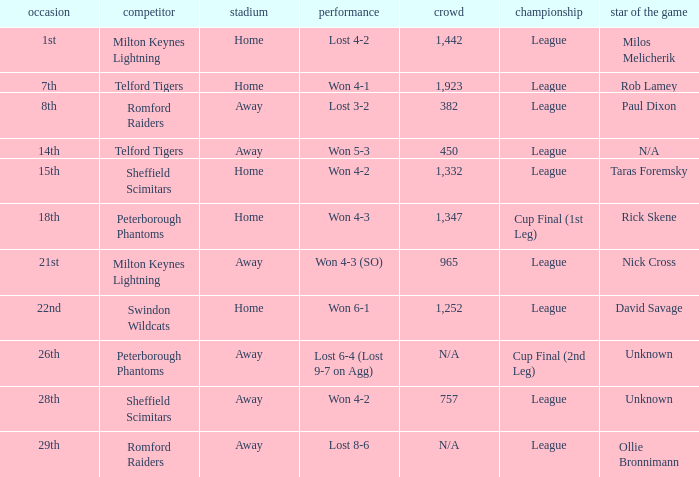What competition was held on the 26th? Cup Final (2nd Leg). Could you parse the entire table as a dict? {'header': ['occasion', 'competitor', 'stadium', 'performance', 'crowd', 'championship', 'star of the game'], 'rows': [['1st', 'Milton Keynes Lightning', 'Home', 'Lost 4-2', '1,442', 'League', 'Milos Melicherik'], ['7th', 'Telford Tigers', 'Home', 'Won 4-1', '1,923', 'League', 'Rob Lamey'], ['8th', 'Romford Raiders', 'Away', 'Lost 3-2', '382', 'League', 'Paul Dixon'], ['14th', 'Telford Tigers', 'Away', 'Won 5-3', '450', 'League', 'N/A'], ['15th', 'Sheffield Scimitars', 'Home', 'Won 4-2', '1,332', 'League', 'Taras Foremsky'], ['18th', 'Peterborough Phantoms', 'Home', 'Won 4-3', '1,347', 'Cup Final (1st Leg)', 'Rick Skene'], ['21st', 'Milton Keynes Lightning', 'Away', 'Won 4-3 (SO)', '965', 'League', 'Nick Cross'], ['22nd', 'Swindon Wildcats', 'Home', 'Won 6-1', '1,252', 'League', 'David Savage'], ['26th', 'Peterborough Phantoms', 'Away', 'Lost 6-4 (Lost 9-7 on Agg)', 'N/A', 'Cup Final (2nd Leg)', 'Unknown'], ['28th', 'Sheffield Scimitars', 'Away', 'Won 4-2', '757', 'League', 'Unknown'], ['29th', 'Romford Raiders', 'Away', 'Lost 8-6', 'N/A', 'League', 'Ollie Bronnimann']]} 